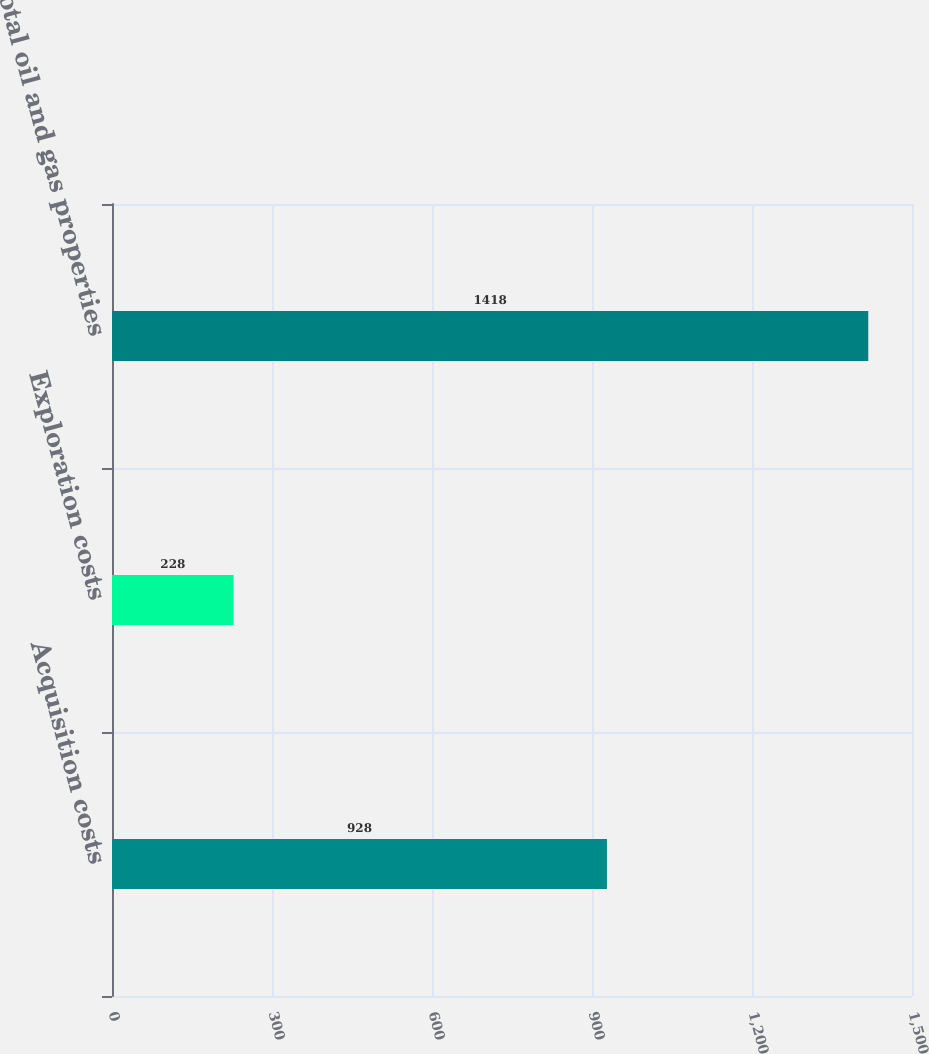Convert chart to OTSL. <chart><loc_0><loc_0><loc_500><loc_500><bar_chart><fcel>Acquisition costs<fcel>Exploration costs<fcel>Total oil and gas properties<nl><fcel>928<fcel>228<fcel>1418<nl></chart> 